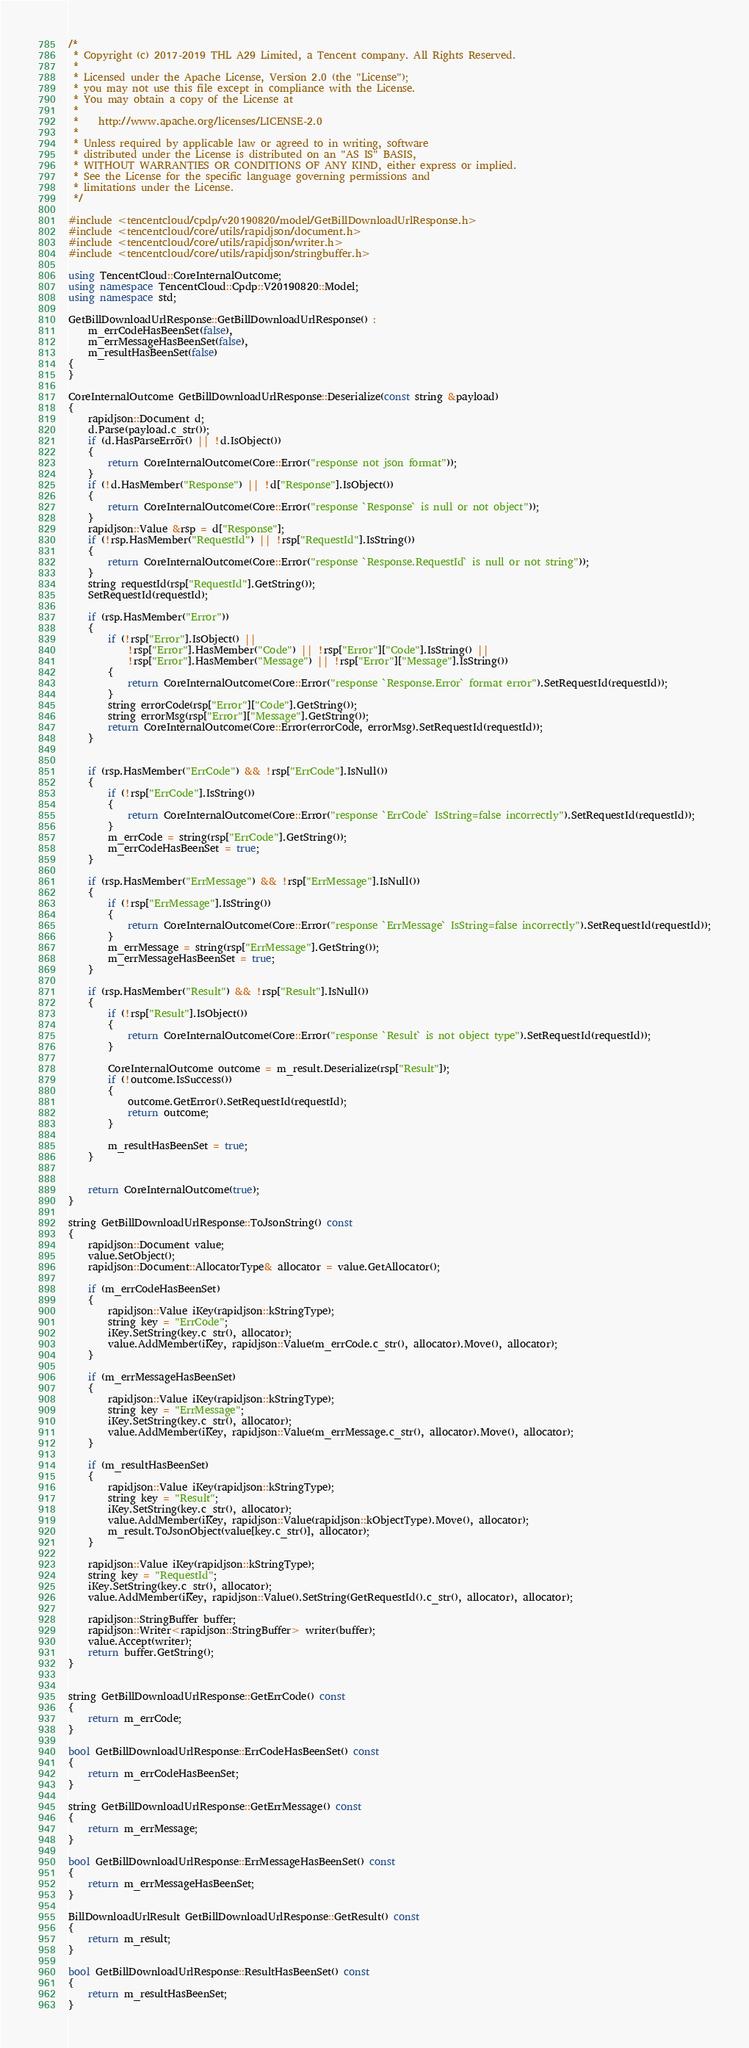<code> <loc_0><loc_0><loc_500><loc_500><_C++_>/*
 * Copyright (c) 2017-2019 THL A29 Limited, a Tencent company. All Rights Reserved.
 *
 * Licensed under the Apache License, Version 2.0 (the "License");
 * you may not use this file except in compliance with the License.
 * You may obtain a copy of the License at
 *
 *    http://www.apache.org/licenses/LICENSE-2.0
 *
 * Unless required by applicable law or agreed to in writing, software
 * distributed under the License is distributed on an "AS IS" BASIS,
 * WITHOUT WARRANTIES OR CONDITIONS OF ANY KIND, either express or implied.
 * See the License for the specific language governing permissions and
 * limitations under the License.
 */

#include <tencentcloud/cpdp/v20190820/model/GetBillDownloadUrlResponse.h>
#include <tencentcloud/core/utils/rapidjson/document.h>
#include <tencentcloud/core/utils/rapidjson/writer.h>
#include <tencentcloud/core/utils/rapidjson/stringbuffer.h>

using TencentCloud::CoreInternalOutcome;
using namespace TencentCloud::Cpdp::V20190820::Model;
using namespace std;

GetBillDownloadUrlResponse::GetBillDownloadUrlResponse() :
    m_errCodeHasBeenSet(false),
    m_errMessageHasBeenSet(false),
    m_resultHasBeenSet(false)
{
}

CoreInternalOutcome GetBillDownloadUrlResponse::Deserialize(const string &payload)
{
    rapidjson::Document d;
    d.Parse(payload.c_str());
    if (d.HasParseError() || !d.IsObject())
    {
        return CoreInternalOutcome(Core::Error("response not json format"));
    }
    if (!d.HasMember("Response") || !d["Response"].IsObject())
    {
        return CoreInternalOutcome(Core::Error("response `Response` is null or not object"));
    }
    rapidjson::Value &rsp = d["Response"];
    if (!rsp.HasMember("RequestId") || !rsp["RequestId"].IsString())
    {
        return CoreInternalOutcome(Core::Error("response `Response.RequestId` is null or not string"));
    }
    string requestId(rsp["RequestId"].GetString());
    SetRequestId(requestId);

    if (rsp.HasMember("Error"))
    {
        if (!rsp["Error"].IsObject() ||
            !rsp["Error"].HasMember("Code") || !rsp["Error"]["Code"].IsString() ||
            !rsp["Error"].HasMember("Message") || !rsp["Error"]["Message"].IsString())
        {
            return CoreInternalOutcome(Core::Error("response `Response.Error` format error").SetRequestId(requestId));
        }
        string errorCode(rsp["Error"]["Code"].GetString());
        string errorMsg(rsp["Error"]["Message"].GetString());
        return CoreInternalOutcome(Core::Error(errorCode, errorMsg).SetRequestId(requestId));
    }


    if (rsp.HasMember("ErrCode") && !rsp["ErrCode"].IsNull())
    {
        if (!rsp["ErrCode"].IsString())
        {
            return CoreInternalOutcome(Core::Error("response `ErrCode` IsString=false incorrectly").SetRequestId(requestId));
        }
        m_errCode = string(rsp["ErrCode"].GetString());
        m_errCodeHasBeenSet = true;
    }

    if (rsp.HasMember("ErrMessage") && !rsp["ErrMessage"].IsNull())
    {
        if (!rsp["ErrMessage"].IsString())
        {
            return CoreInternalOutcome(Core::Error("response `ErrMessage` IsString=false incorrectly").SetRequestId(requestId));
        }
        m_errMessage = string(rsp["ErrMessage"].GetString());
        m_errMessageHasBeenSet = true;
    }

    if (rsp.HasMember("Result") && !rsp["Result"].IsNull())
    {
        if (!rsp["Result"].IsObject())
        {
            return CoreInternalOutcome(Core::Error("response `Result` is not object type").SetRequestId(requestId));
        }

        CoreInternalOutcome outcome = m_result.Deserialize(rsp["Result"]);
        if (!outcome.IsSuccess())
        {
            outcome.GetError().SetRequestId(requestId);
            return outcome;
        }

        m_resultHasBeenSet = true;
    }


    return CoreInternalOutcome(true);
}

string GetBillDownloadUrlResponse::ToJsonString() const
{
    rapidjson::Document value;
    value.SetObject();
    rapidjson::Document::AllocatorType& allocator = value.GetAllocator();

    if (m_errCodeHasBeenSet)
    {
        rapidjson::Value iKey(rapidjson::kStringType);
        string key = "ErrCode";
        iKey.SetString(key.c_str(), allocator);
        value.AddMember(iKey, rapidjson::Value(m_errCode.c_str(), allocator).Move(), allocator);
    }

    if (m_errMessageHasBeenSet)
    {
        rapidjson::Value iKey(rapidjson::kStringType);
        string key = "ErrMessage";
        iKey.SetString(key.c_str(), allocator);
        value.AddMember(iKey, rapidjson::Value(m_errMessage.c_str(), allocator).Move(), allocator);
    }

    if (m_resultHasBeenSet)
    {
        rapidjson::Value iKey(rapidjson::kStringType);
        string key = "Result";
        iKey.SetString(key.c_str(), allocator);
        value.AddMember(iKey, rapidjson::Value(rapidjson::kObjectType).Move(), allocator);
        m_result.ToJsonObject(value[key.c_str()], allocator);
    }

    rapidjson::Value iKey(rapidjson::kStringType);
    string key = "RequestId";
    iKey.SetString(key.c_str(), allocator);
    value.AddMember(iKey, rapidjson::Value().SetString(GetRequestId().c_str(), allocator), allocator);
    
    rapidjson::StringBuffer buffer;
    rapidjson::Writer<rapidjson::StringBuffer> writer(buffer);
    value.Accept(writer);
    return buffer.GetString();
}


string GetBillDownloadUrlResponse::GetErrCode() const
{
    return m_errCode;
}

bool GetBillDownloadUrlResponse::ErrCodeHasBeenSet() const
{
    return m_errCodeHasBeenSet;
}

string GetBillDownloadUrlResponse::GetErrMessage() const
{
    return m_errMessage;
}

bool GetBillDownloadUrlResponse::ErrMessageHasBeenSet() const
{
    return m_errMessageHasBeenSet;
}

BillDownloadUrlResult GetBillDownloadUrlResponse::GetResult() const
{
    return m_result;
}

bool GetBillDownloadUrlResponse::ResultHasBeenSet() const
{
    return m_resultHasBeenSet;
}


</code> 